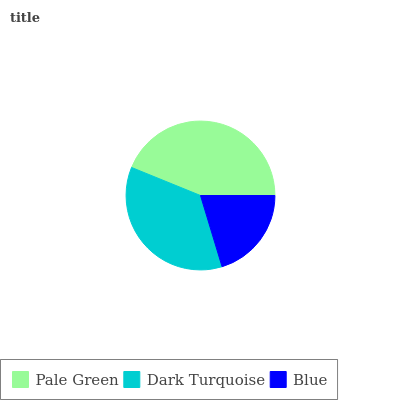Is Blue the minimum?
Answer yes or no. Yes. Is Pale Green the maximum?
Answer yes or no. Yes. Is Dark Turquoise the minimum?
Answer yes or no. No. Is Dark Turquoise the maximum?
Answer yes or no. No. Is Pale Green greater than Dark Turquoise?
Answer yes or no. Yes. Is Dark Turquoise less than Pale Green?
Answer yes or no. Yes. Is Dark Turquoise greater than Pale Green?
Answer yes or no. No. Is Pale Green less than Dark Turquoise?
Answer yes or no. No. Is Dark Turquoise the high median?
Answer yes or no. Yes. Is Dark Turquoise the low median?
Answer yes or no. Yes. Is Blue the high median?
Answer yes or no. No. Is Pale Green the low median?
Answer yes or no. No. 